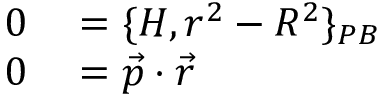<formula> <loc_0><loc_0><loc_500><loc_500>\begin{array} { r l } { 0 } & = \{ H , r ^ { 2 } - R ^ { 2 } \} _ { P B } } \\ { 0 } & = { \vec { p } } \cdot { \vec { r } } } \end{array}</formula> 